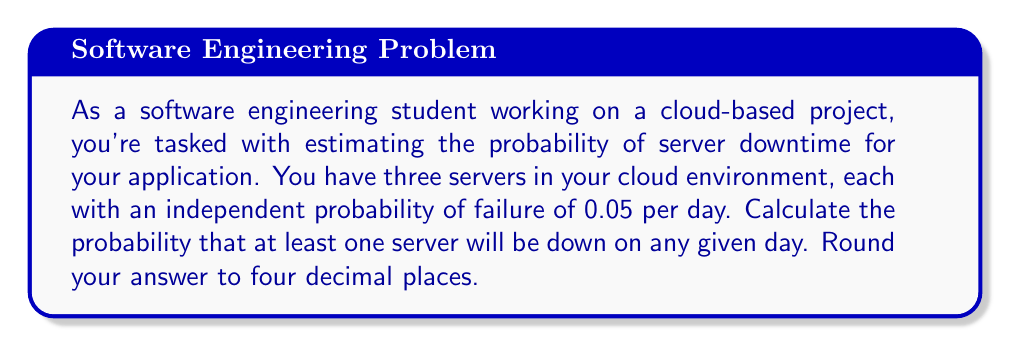Could you help me with this problem? To solve this problem, we'll use the concept of probability of complementary events. Instead of directly calculating the probability of at least one server being down, we'll calculate the probability of all servers being up and then subtract that from 1.

Let's break it down step-by-step:

1) First, let's define our events:
   $P(\text{server up}) = 1 - 0.05 = 0.95$
   $P(\text{server down}) = 0.05$

2) The probability of all servers being up is the product of individual probabilities (since they're independent):

   $P(\text{all servers up}) = 0.95 \times 0.95 \times 0.95 = 0.95^3$

3) Now, we can calculate the probability of at least one server being down:

   $P(\text{at least one server down}) = 1 - P(\text{all servers up})$
   
   $= 1 - 0.95^3$

4) Let's compute this:

   $1 - 0.95^3 = 1 - 0.857375 = 0.142625$

5) Rounding to four decimal places:

   $0.142625 \approx 0.1426$

Therefore, the probability that at least one server will be down on any given day is approximately 0.1426 or 14.26%.
Answer: 0.1426 